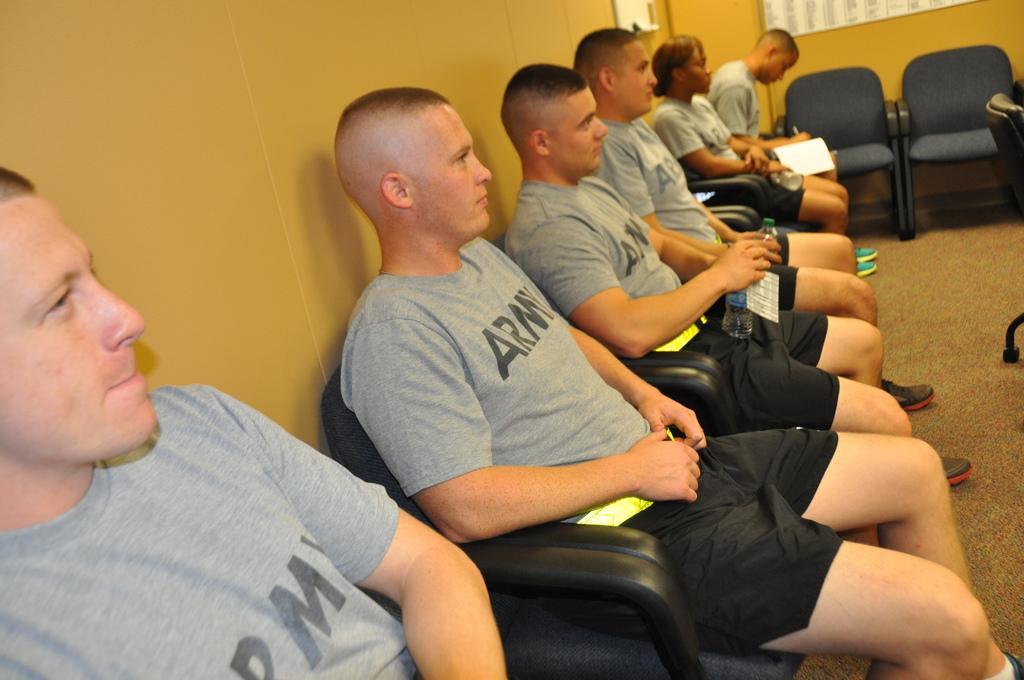In one or two sentences, can you explain what this image depicts? On the background we can see wall., chairs. here we can see all the persons sitting on chairs and few are holding water bottles in their hands. This is a floor. 